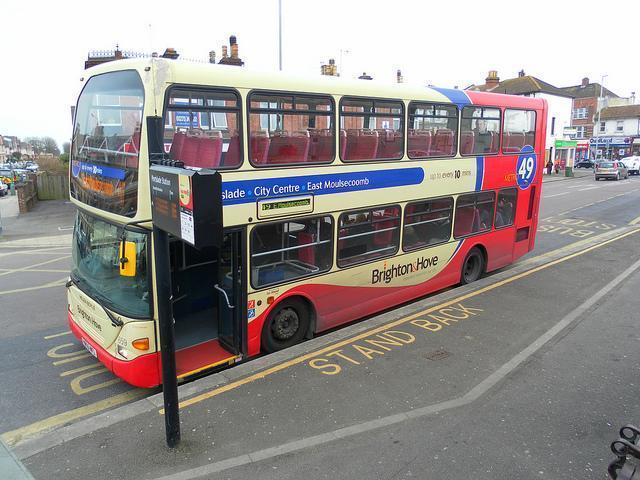How many levels does the bus have?
Give a very brief answer. 2. How many train tracks are there?
Give a very brief answer. 0. 